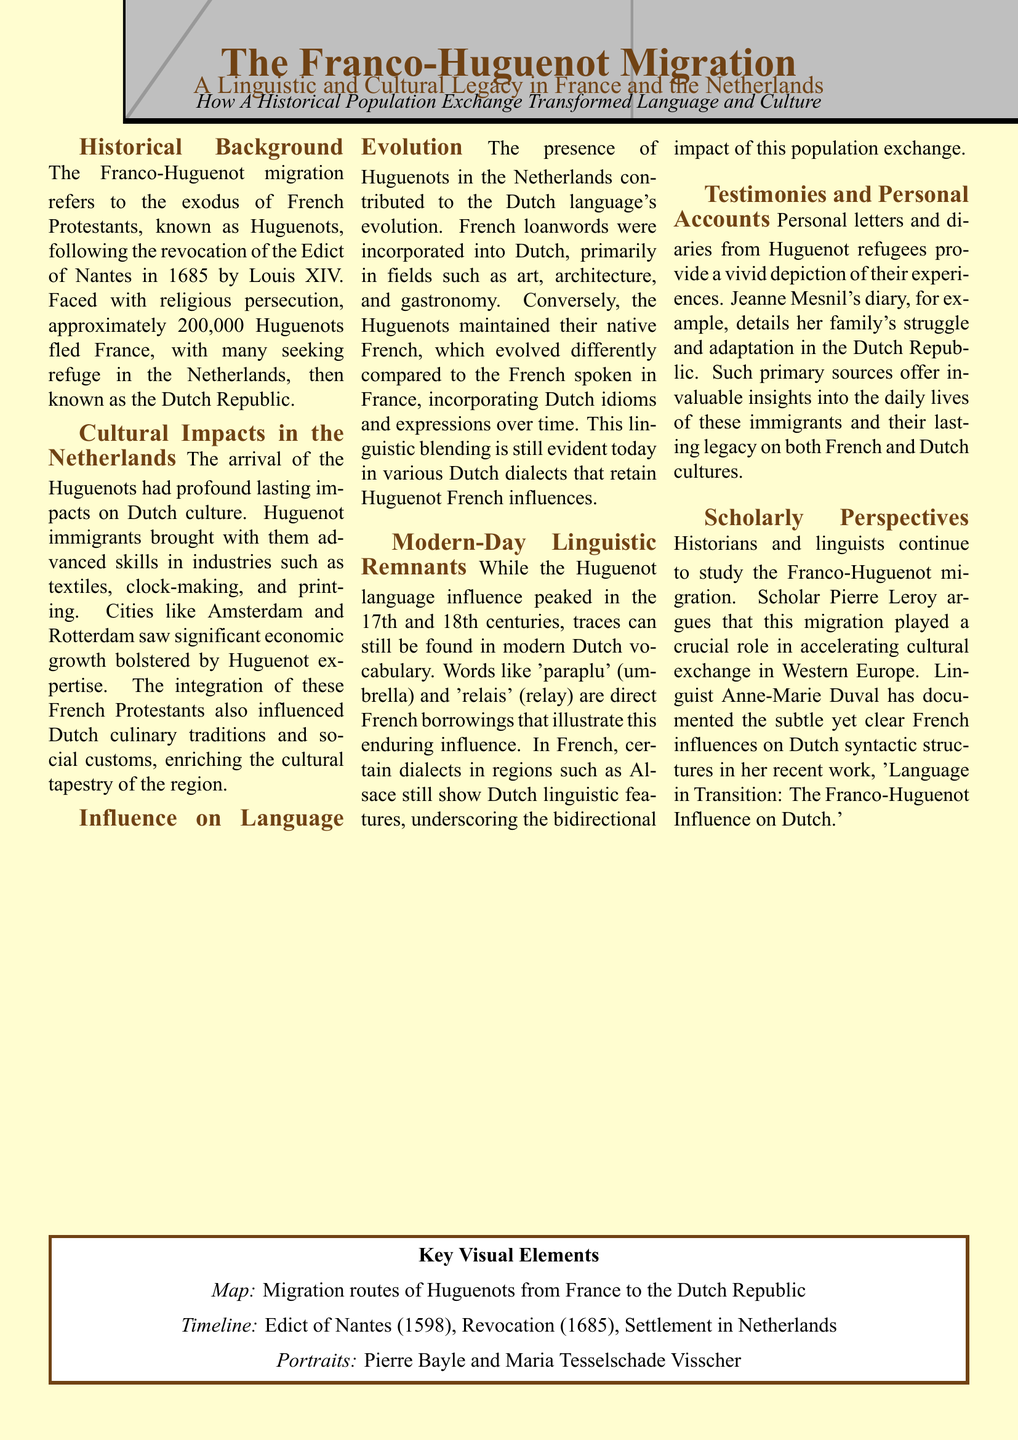What is the total number of Huguenots that fled France? The document states that approximately 200,000 Huguenots fled France following the revocation of the Edict of Nantes.
Answer: 200,000 What was the Edict of Nantes? The document mentions the Edict of Nantes was issued in 1598 and was revoked in 1685, referring to a historical law concerning religious tolerance in France.
Answer: 1598 Which city is mentioned as benefiting economically from Huguenot expertise? The document states that cities like Amsterdam saw significant economic growth due to Huguenot skills and knowledge in various industries.
Answer: Amsterdam What type of remnants are noted in modern Dutch vocabulary? The document highlights that modern Dutch contains French loanwords as a result of Huguenot influence, illustrating this linguistic blending.
Answer: French loanwords Who documented the French influences on Dutch syntax? The document states that linguist Anne-Marie Duval has documented the influences in her work titled 'Language in Transition: The Franco-Huguenot Influence on Dutch.'
Answer: Anne-Marie Duval What diary provides insights into the experiences of Huguenot refugees? The document refers to Jeanne Mesnil's diary, which details her family's struggles and adaptation in the Dutch Republic.
Answer: Jeanne Mesnil What skill did Huguenots contribute to Dutch culture? The document mentions that Huguenots brought advanced skills particularly in the textile industry, influencing local economic growth.
Answer: Textiles What type of historical document is this content presented in? The format of the information, including sections and mixed columns, indicates it is presented in a newspaper layout designed to convey cultural history and linguistic influence.
Answer: Newspaper layout What are two locations noted for their Huguenot settlement in the Netherlands? The document specifies Amsterdam and Rotterdam as key cities where Huguenots settled and contributed to local culture and economy.
Answer: Amsterdam and Rotterdam 